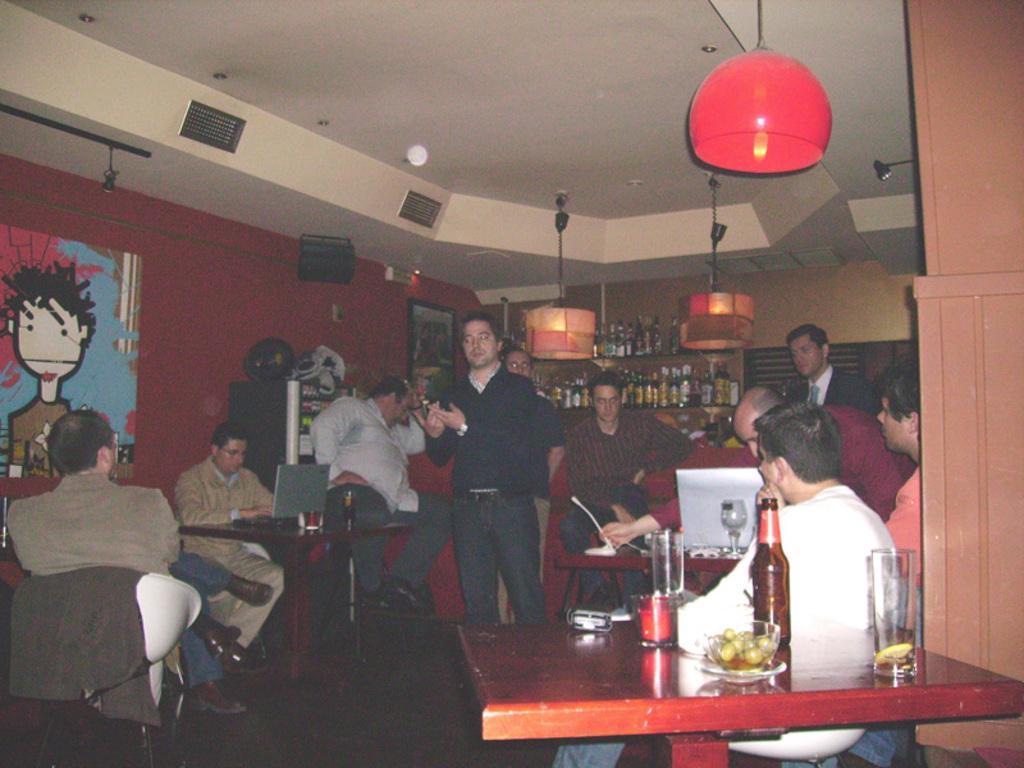Could you give a brief overview of what you see in this image? In this image I can see the group of people sitting in front of the table. On the table there is a glass,bottle and the bowl. At the back there is a wine rack. 